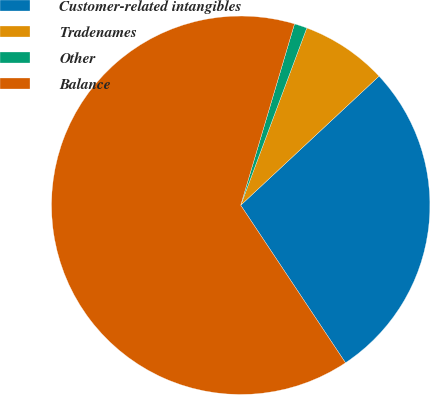Convert chart. <chart><loc_0><loc_0><loc_500><loc_500><pie_chart><fcel>Customer-related intangibles<fcel>Tradenames<fcel>Other<fcel>Balance<nl><fcel>27.61%<fcel>7.37%<fcel>1.09%<fcel>63.93%<nl></chart> 